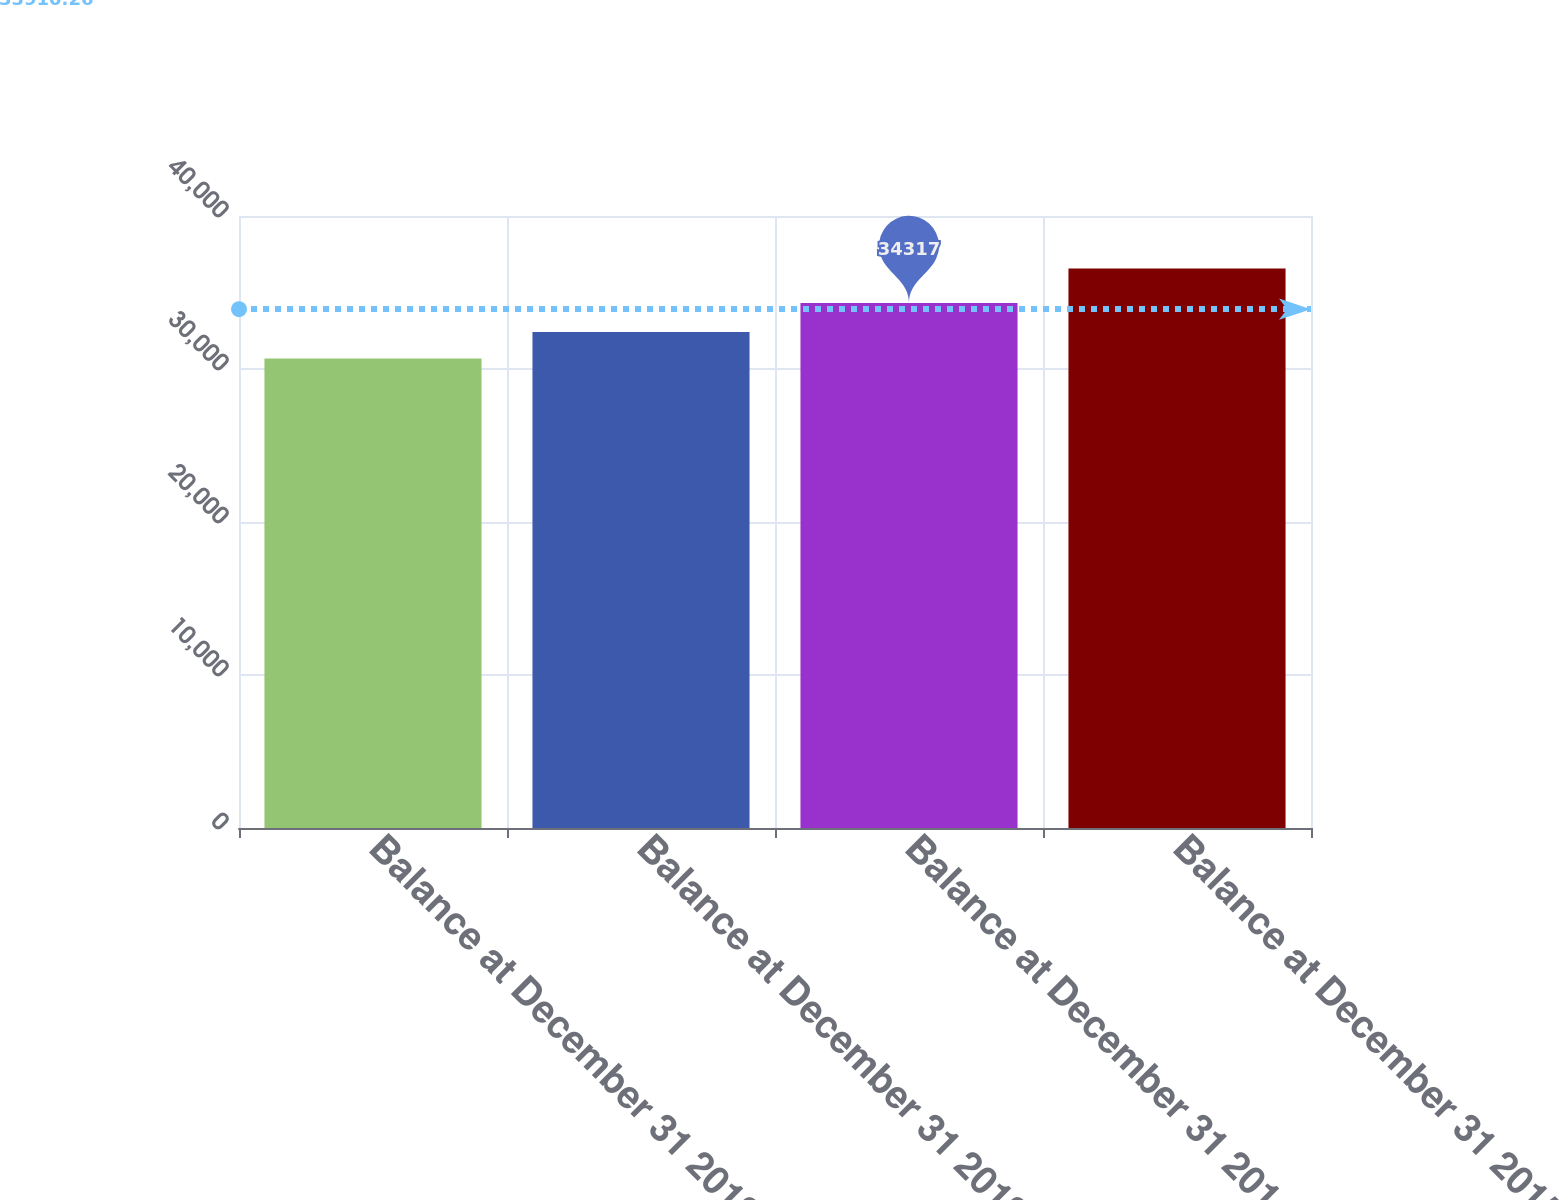Convert chart to OTSL. <chart><loc_0><loc_0><loc_500><loc_500><bar_chart><fcel>Balance at December 31 2012<fcel>Balance at December 31 2013<fcel>Balance at December 31 2014<fcel>Balance at December 31 2015<nl><fcel>30679<fcel>32416<fcel>34317<fcel>36575<nl></chart> 